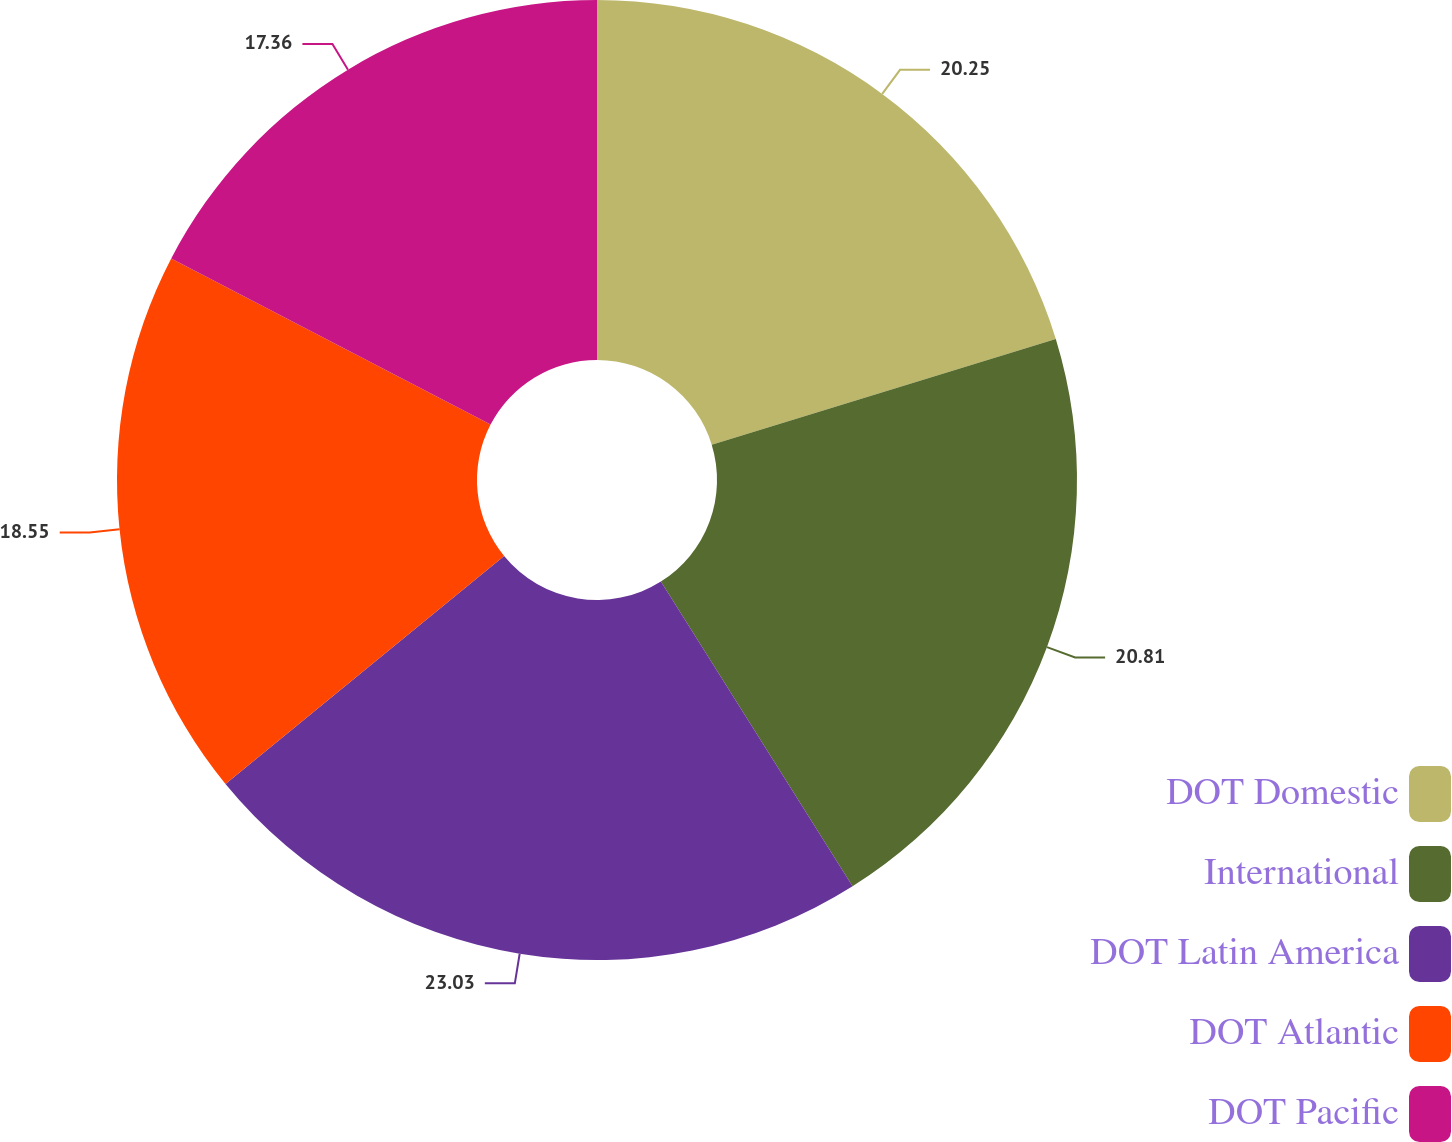Convert chart to OTSL. <chart><loc_0><loc_0><loc_500><loc_500><pie_chart><fcel>DOT Domestic<fcel>International<fcel>DOT Latin America<fcel>DOT Atlantic<fcel>DOT Pacific<nl><fcel>20.25%<fcel>20.81%<fcel>23.02%<fcel>18.55%<fcel>17.36%<nl></chart> 